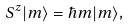<formula> <loc_0><loc_0><loc_500><loc_500>S ^ { z } | m \rangle = \hbar { m } | m \rangle ,</formula> 